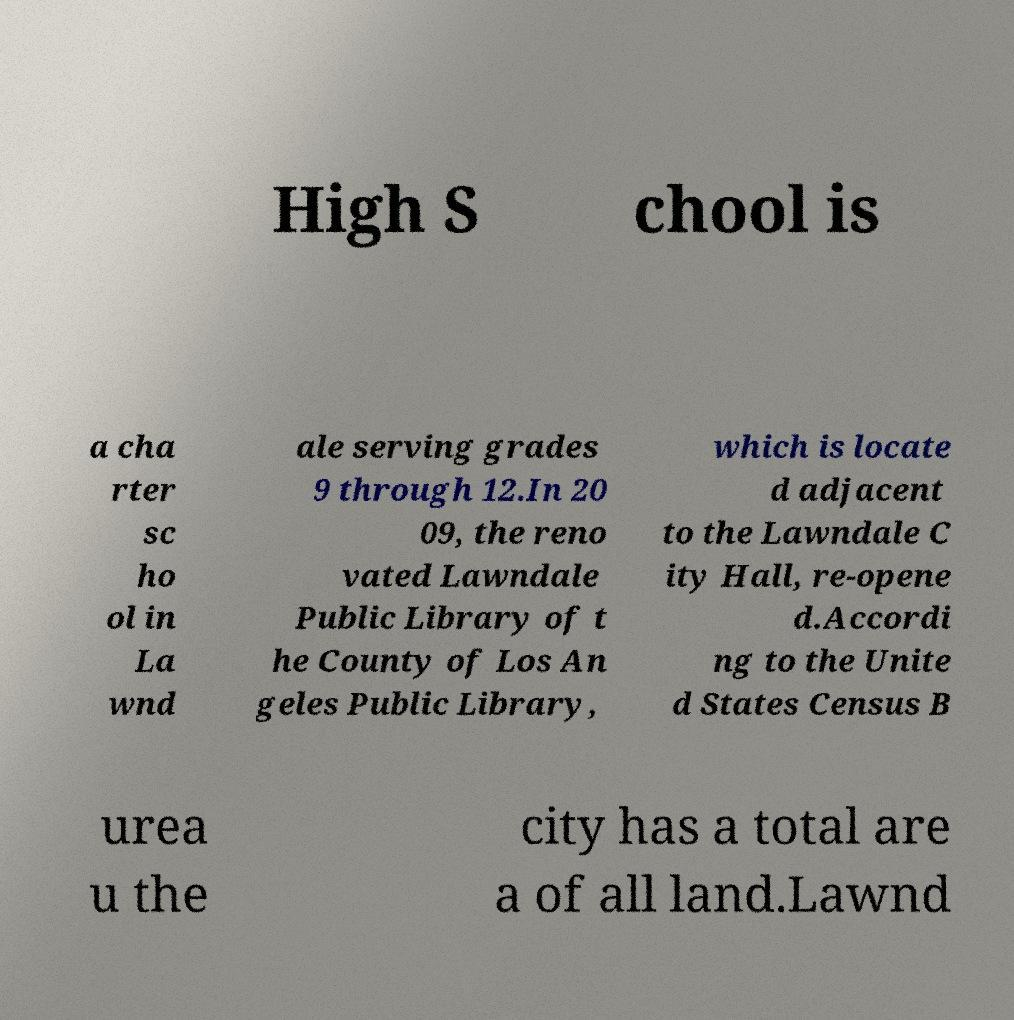What messages or text are displayed in this image? I need them in a readable, typed format. High S chool is a cha rter sc ho ol in La wnd ale serving grades 9 through 12.In 20 09, the reno vated Lawndale Public Library of t he County of Los An geles Public Library, which is locate d adjacent to the Lawndale C ity Hall, re-opene d.Accordi ng to the Unite d States Census B urea u the city has a total are a of all land.Lawnd 